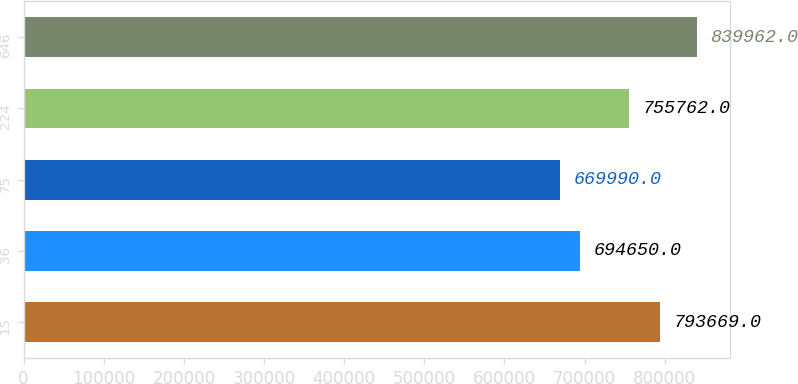Convert chart. <chart><loc_0><loc_0><loc_500><loc_500><bar_chart><fcel>15<fcel>36<fcel>75<fcel>224<fcel>646<nl><fcel>793669<fcel>694650<fcel>669990<fcel>755762<fcel>839962<nl></chart> 